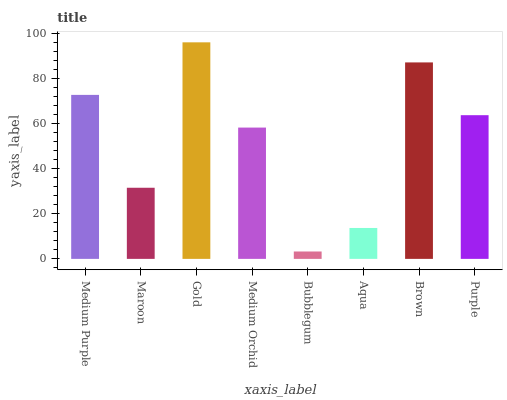Is Maroon the minimum?
Answer yes or no. No. Is Maroon the maximum?
Answer yes or no. No. Is Medium Purple greater than Maroon?
Answer yes or no. Yes. Is Maroon less than Medium Purple?
Answer yes or no. Yes. Is Maroon greater than Medium Purple?
Answer yes or no. No. Is Medium Purple less than Maroon?
Answer yes or no. No. Is Purple the high median?
Answer yes or no. Yes. Is Medium Orchid the low median?
Answer yes or no. Yes. Is Medium Orchid the high median?
Answer yes or no. No. Is Purple the low median?
Answer yes or no. No. 